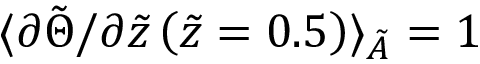<formula> <loc_0><loc_0><loc_500><loc_500>\langle \partial \tilde { \Theta } / \partial \tilde { z } \left ( \tilde { z } = 0 . 5 \right ) \rangle _ { \tilde { A } } = 1</formula> 